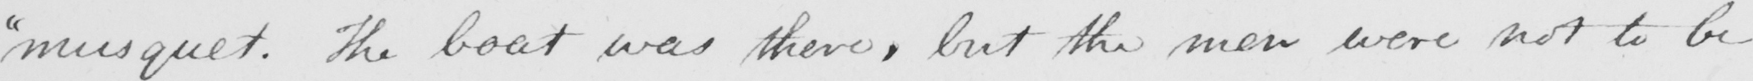What is written in this line of handwriting? " musquet . The boat was there , but the men were not to be 